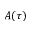Convert formula to latex. <formula><loc_0><loc_0><loc_500><loc_500>A ( \tau )</formula> 